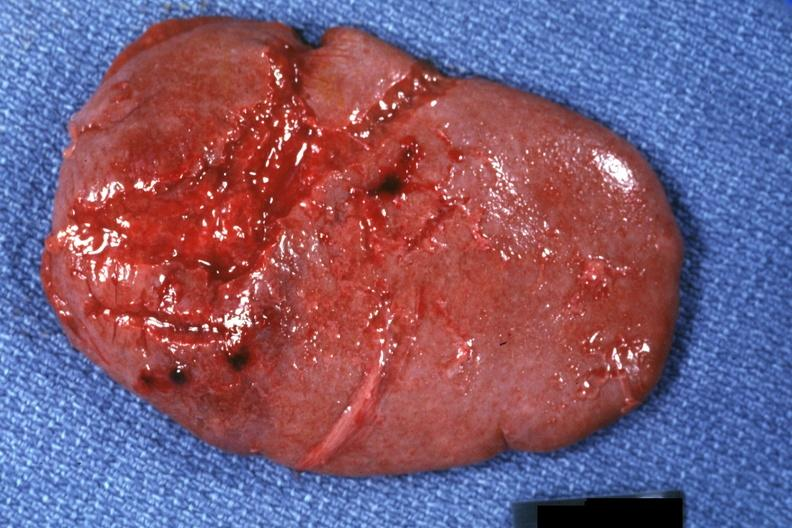s traumatic rupture present?
Answer the question using a single word or phrase. Yes 